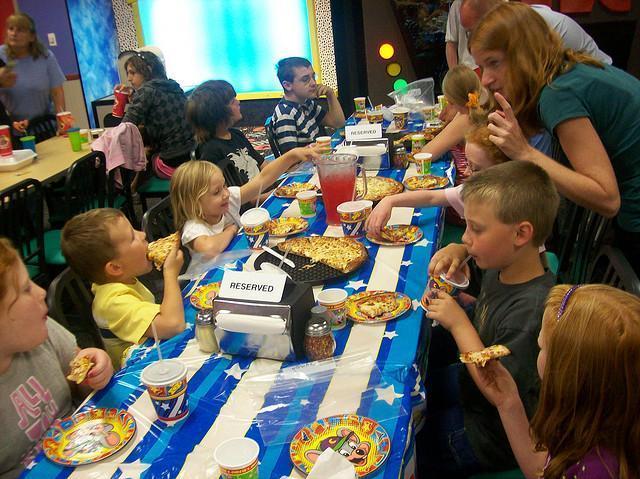How many pizzas are in the photo?
Give a very brief answer. 1. How many cups are there?
Give a very brief answer. 3. How many people can be seen?
Give a very brief answer. 11. How many dining tables are in the photo?
Give a very brief answer. 2. How many chairs are there?
Give a very brief answer. 5. 